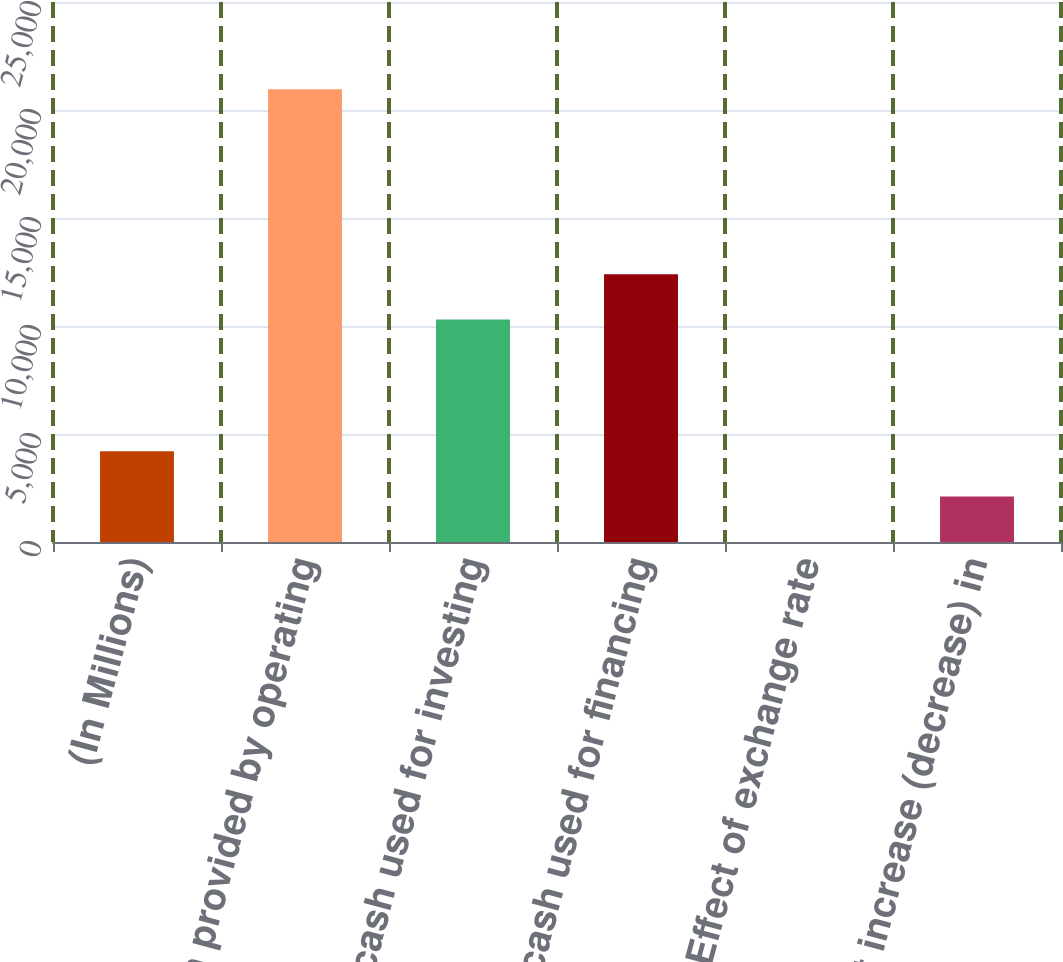Convert chart. <chart><loc_0><loc_0><loc_500><loc_500><bar_chart><fcel>(In Millions)<fcel>Net cash provided by operating<fcel>Net cash used for investing<fcel>Net cash used for financing<fcel>Effect of exchange rate<fcel>Net increase (decrease) in<nl><fcel>4196.6<fcel>20963<fcel>10301<fcel>12396.8<fcel>5<fcel>2100.8<nl></chart> 